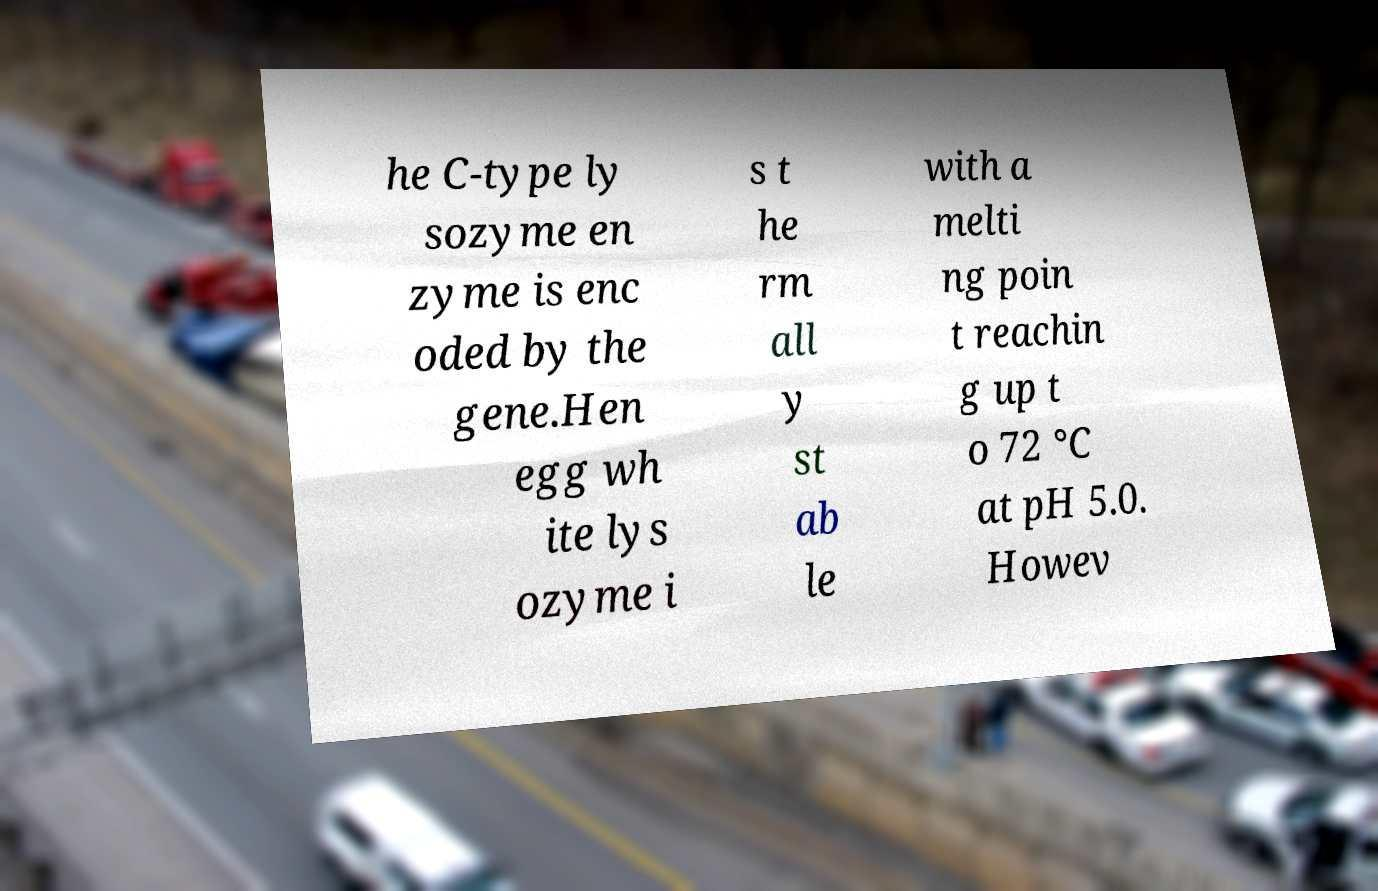What messages or text are displayed in this image? I need them in a readable, typed format. he C-type ly sozyme en zyme is enc oded by the gene.Hen egg wh ite lys ozyme i s t he rm all y st ab le with a melti ng poin t reachin g up t o 72 °C at pH 5.0. Howev 